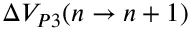Convert formula to latex. <formula><loc_0><loc_0><loc_500><loc_500>\Delta V _ { P 3 } ( n \to n + 1 )</formula> 